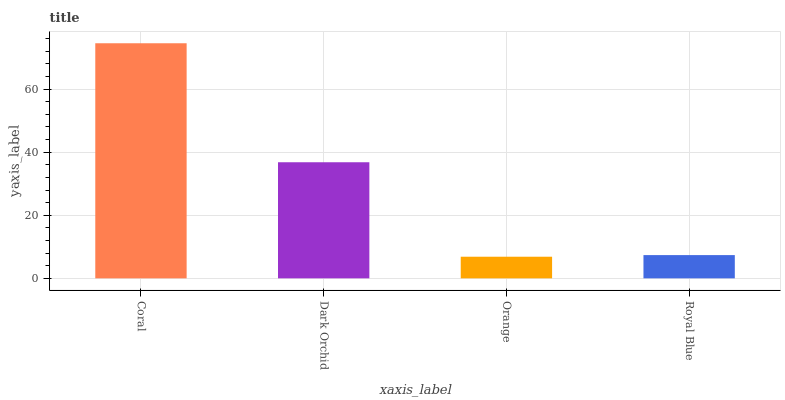Is Dark Orchid the minimum?
Answer yes or no. No. Is Dark Orchid the maximum?
Answer yes or no. No. Is Coral greater than Dark Orchid?
Answer yes or no. Yes. Is Dark Orchid less than Coral?
Answer yes or no. Yes. Is Dark Orchid greater than Coral?
Answer yes or no. No. Is Coral less than Dark Orchid?
Answer yes or no. No. Is Dark Orchid the high median?
Answer yes or no. Yes. Is Royal Blue the low median?
Answer yes or no. Yes. Is Coral the high median?
Answer yes or no. No. Is Coral the low median?
Answer yes or no. No. 